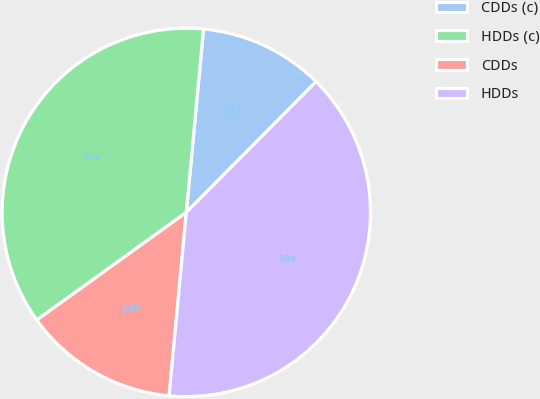Convert chart. <chart><loc_0><loc_0><loc_500><loc_500><pie_chart><fcel>CDDs (c)<fcel>HDDs (c)<fcel>CDDs<fcel>HDDs<nl><fcel>10.95%<fcel>36.42%<fcel>13.58%<fcel>39.05%<nl></chart> 